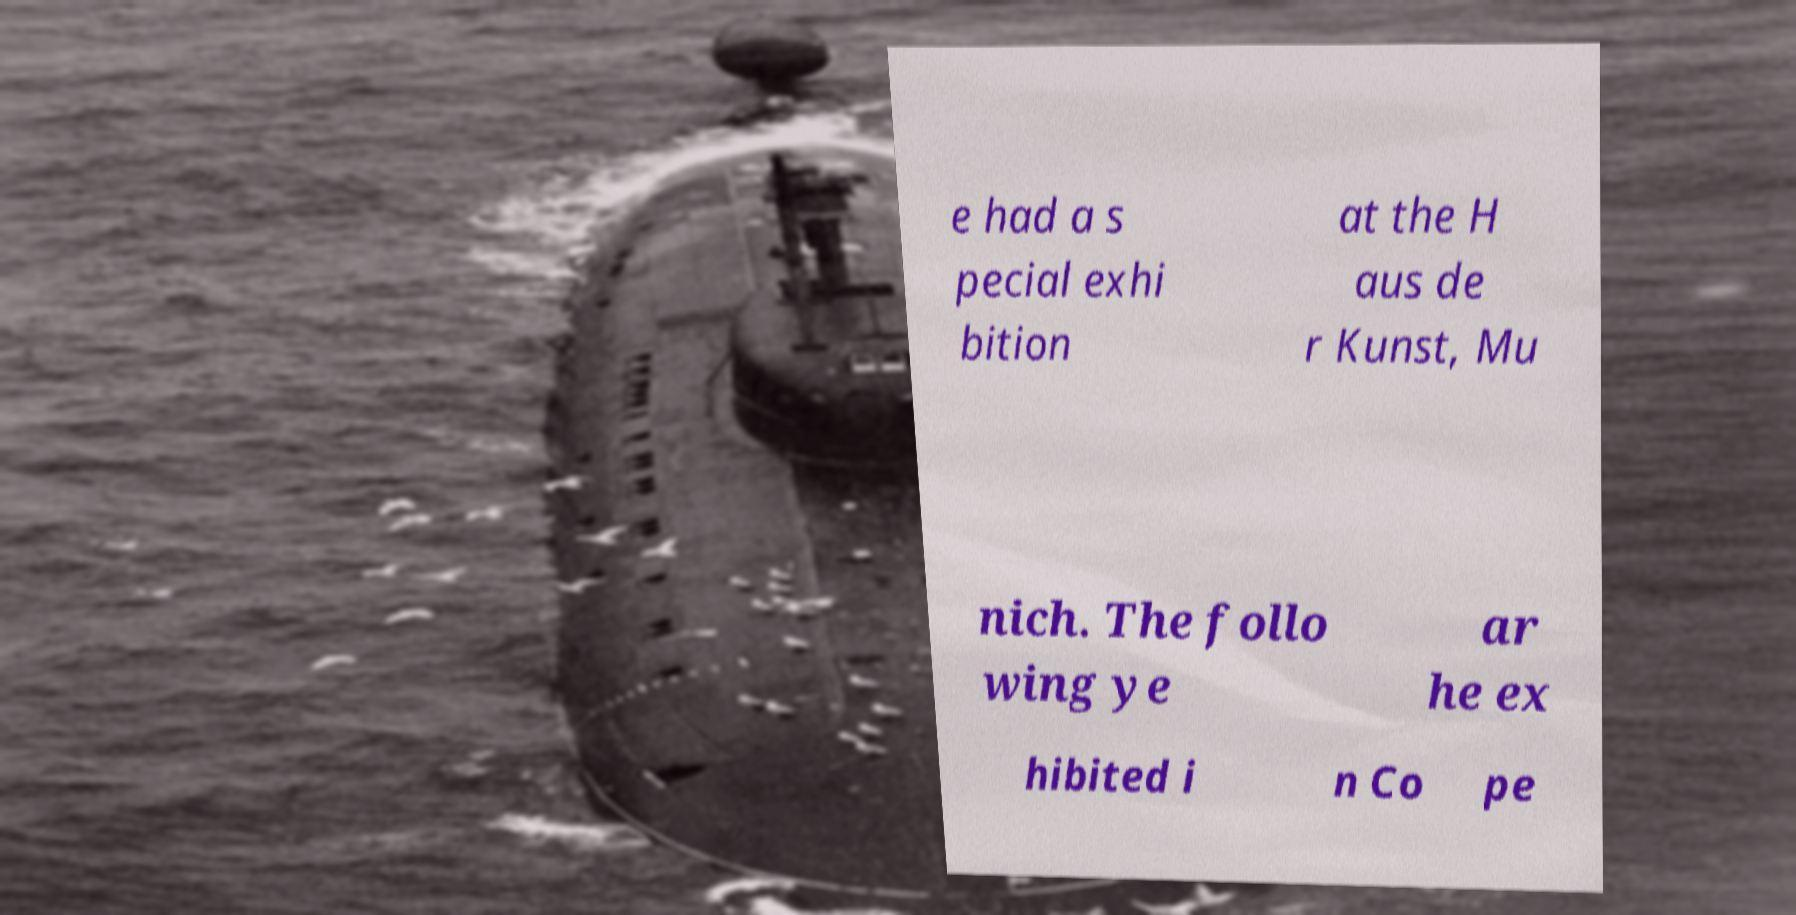Can you accurately transcribe the text from the provided image for me? e had a s pecial exhi bition at the H aus de r Kunst, Mu nich. The follo wing ye ar he ex hibited i n Co pe 